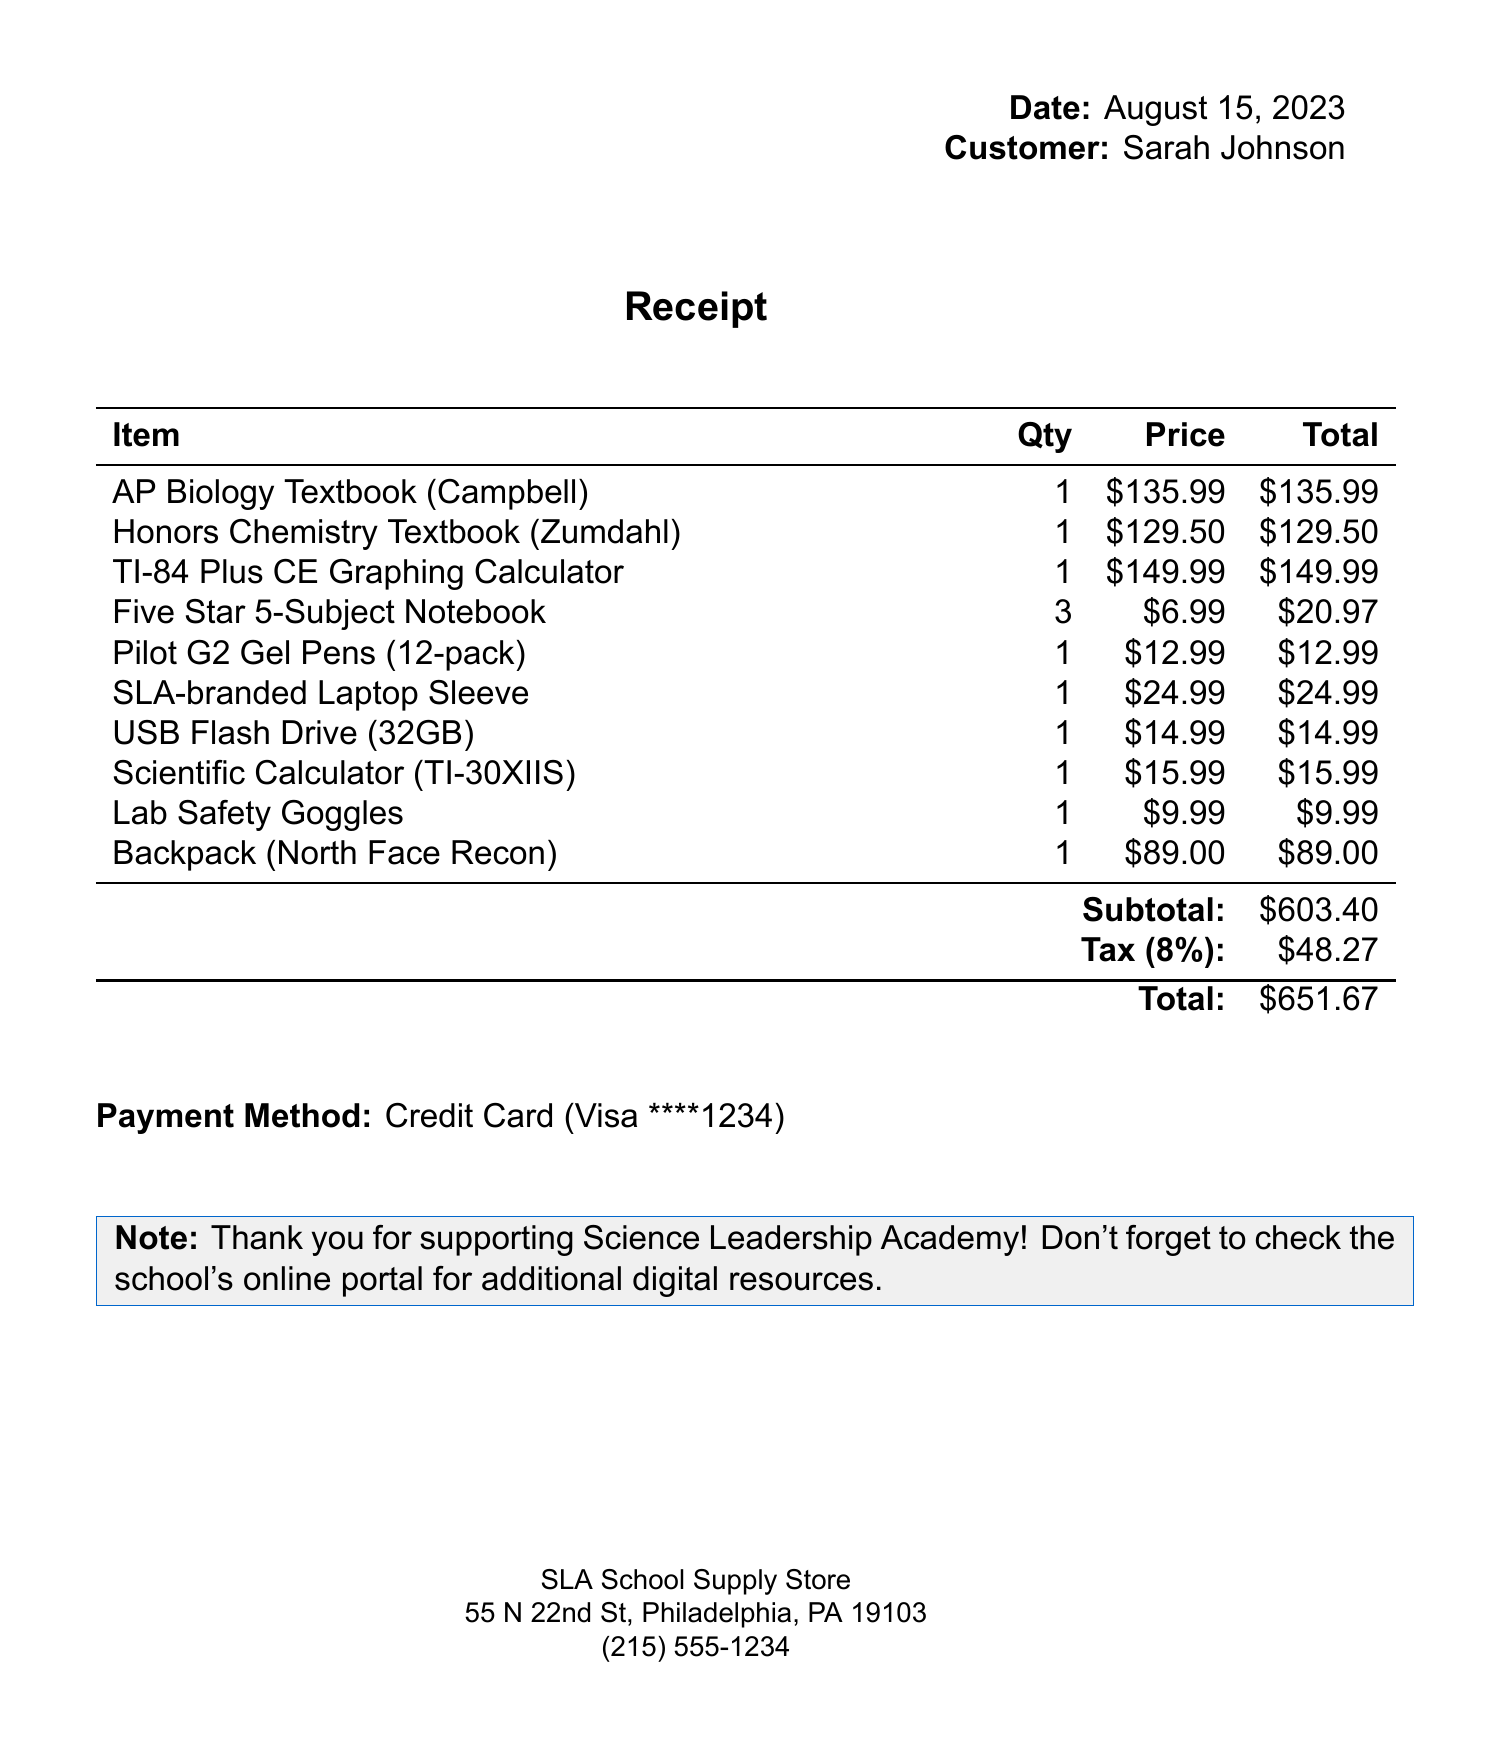What is the store's name? The name of the store is mentioned at the top of the receipt.
Answer: SLA School Supply Store What is the total amount due? The total amount is calculated after adding the subtotal and tax.
Answer: $651.67 Who is the customer? The name of the customer is indicated in the receipt.
Answer: Sarah Johnson What is the quantity of Five Star 5-Subject Notebooks purchased? The quantity is specified next to the item's name in the document.
Answer: 3 What is the subtotal before tax? The subtotal is listed separately before the tax amount is added.
Answer: $603.40 What type of payment was used? The payment method is specified at the bottom of the receipt.
Answer: Credit Card How much tax was charged? The tax amount is mentioned just before the total.
Answer: $48.27 What is the price of the TI-84 Plus CE Graphing Calculator? The price is listed next to the calculator in the items section.
Answer: $149.99 What is the date of the purchase? The purchase date is provided at the top section of the receipt.
Answer: August 15, 2023 